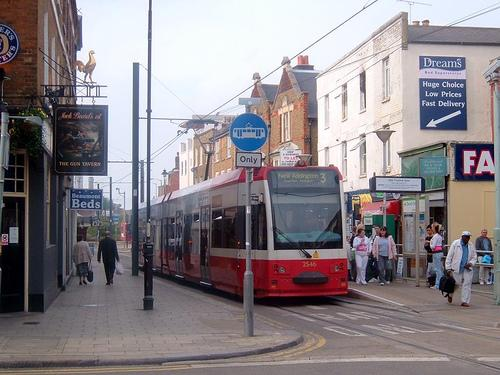In which location does this bus run?

Choices:
A) rural
B) city
C) suburbs
D) farm city 